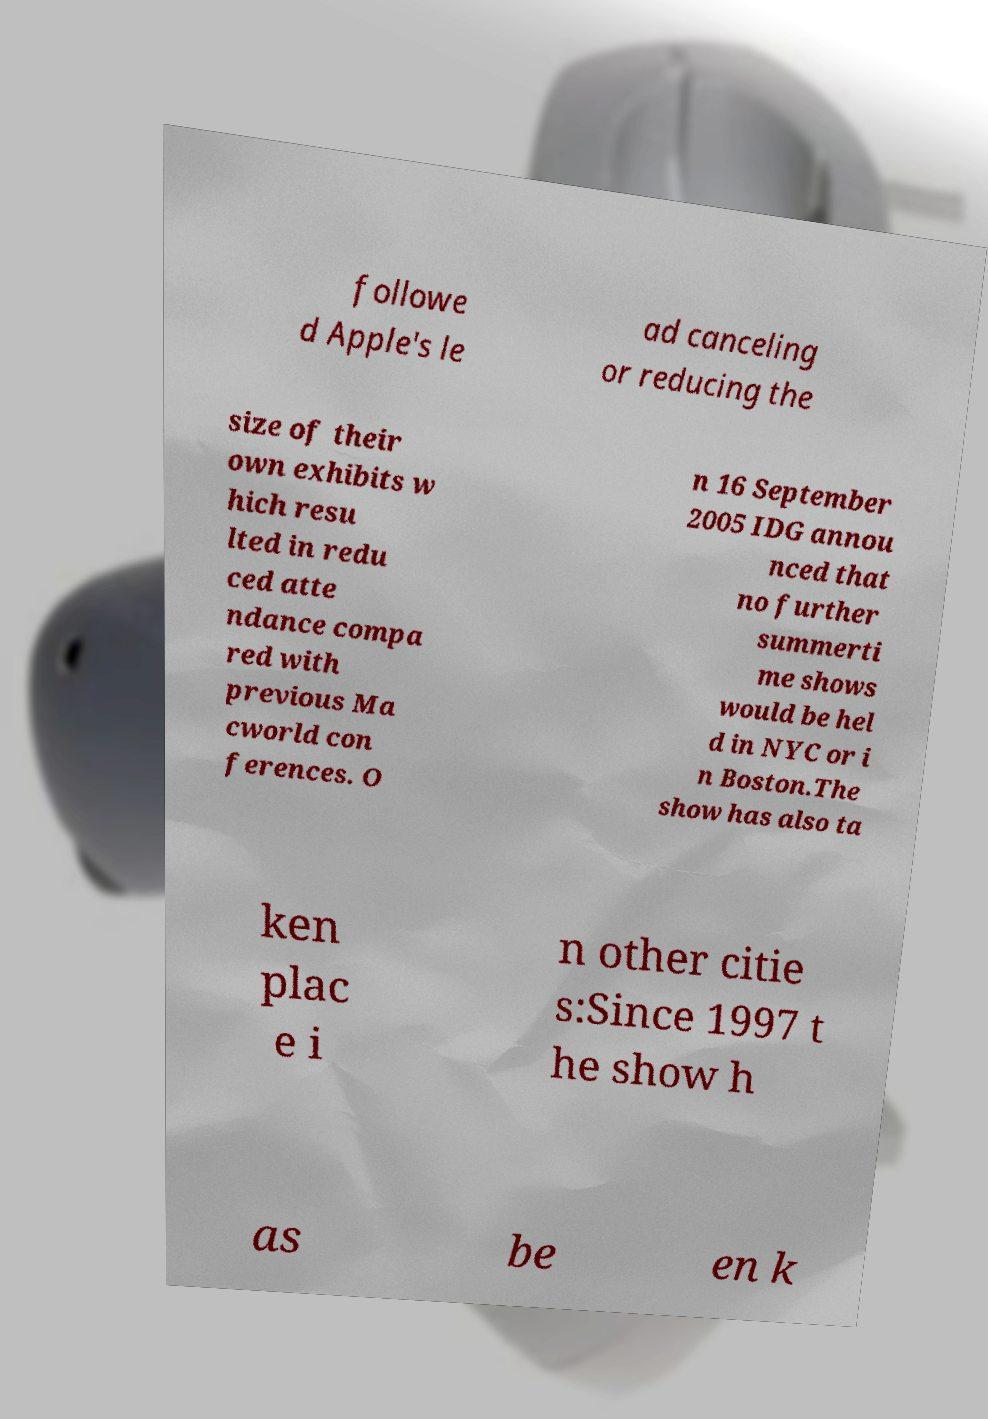I need the written content from this picture converted into text. Can you do that? followe d Apple's le ad canceling or reducing the size of their own exhibits w hich resu lted in redu ced atte ndance compa red with previous Ma cworld con ferences. O n 16 September 2005 IDG annou nced that no further summerti me shows would be hel d in NYC or i n Boston.The show has also ta ken plac e i n other citie s:Since 1997 t he show h as be en k 